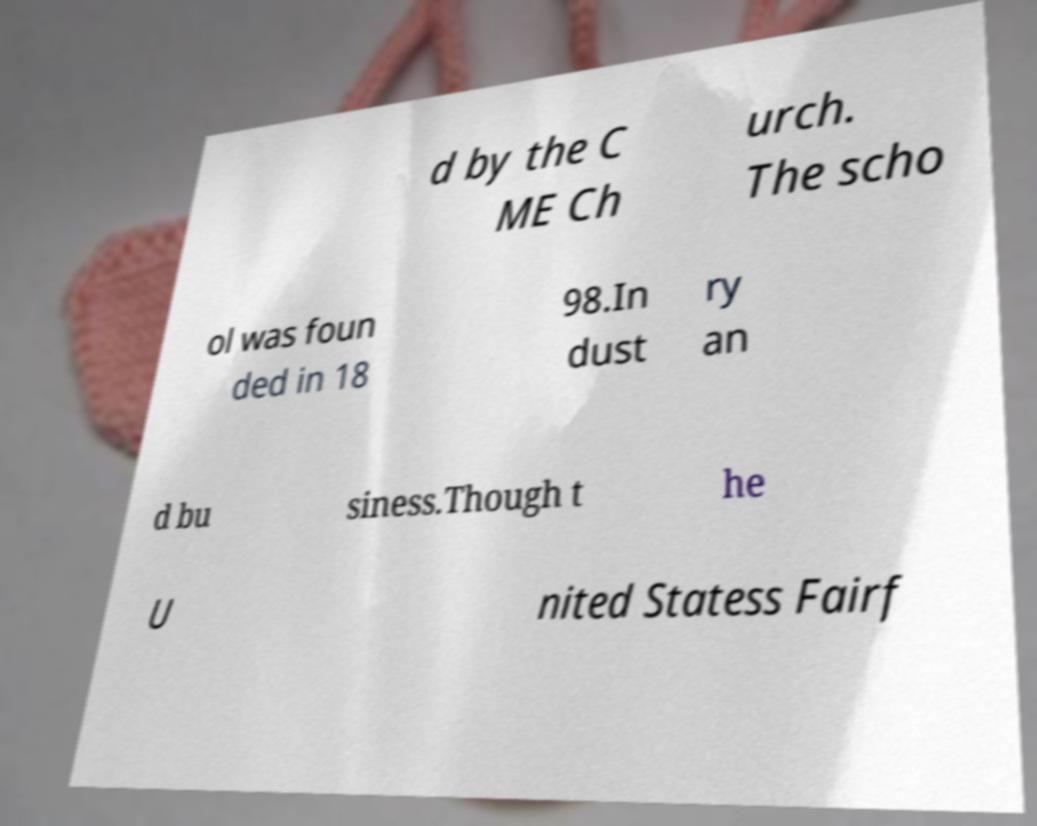Can you read and provide the text displayed in the image?This photo seems to have some interesting text. Can you extract and type it out for me? d by the C ME Ch urch. The scho ol was foun ded in 18 98.In dust ry an d bu siness.Though t he U nited Statess Fairf 